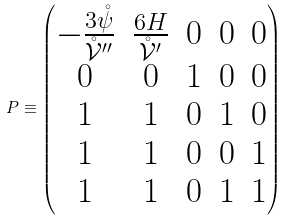Convert formula to latex. <formula><loc_0><loc_0><loc_500><loc_500>P \equiv \begin{pmatrix} - \frac { 3 \mathring { \psi } } { \mathring { \mathcal { V } } ^ { \prime \prime } } & \frac { 6 H } { \mathring { \mathcal { V } } ^ { \prime } } & 0 & 0 & 0 \\ 0 & 0 & 1 & 0 & 0 \\ 1 & 1 & 0 & 1 & 0 \\ 1 & 1 & 0 & 0 & 1 \\ 1 & 1 & 0 & 1 & 1 \end{pmatrix}</formula> 